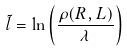<formula> <loc_0><loc_0><loc_500><loc_500>\tilde { l } = \ln \left ( \frac { \rho ( R , L ) } { \lambda } \right )</formula> 